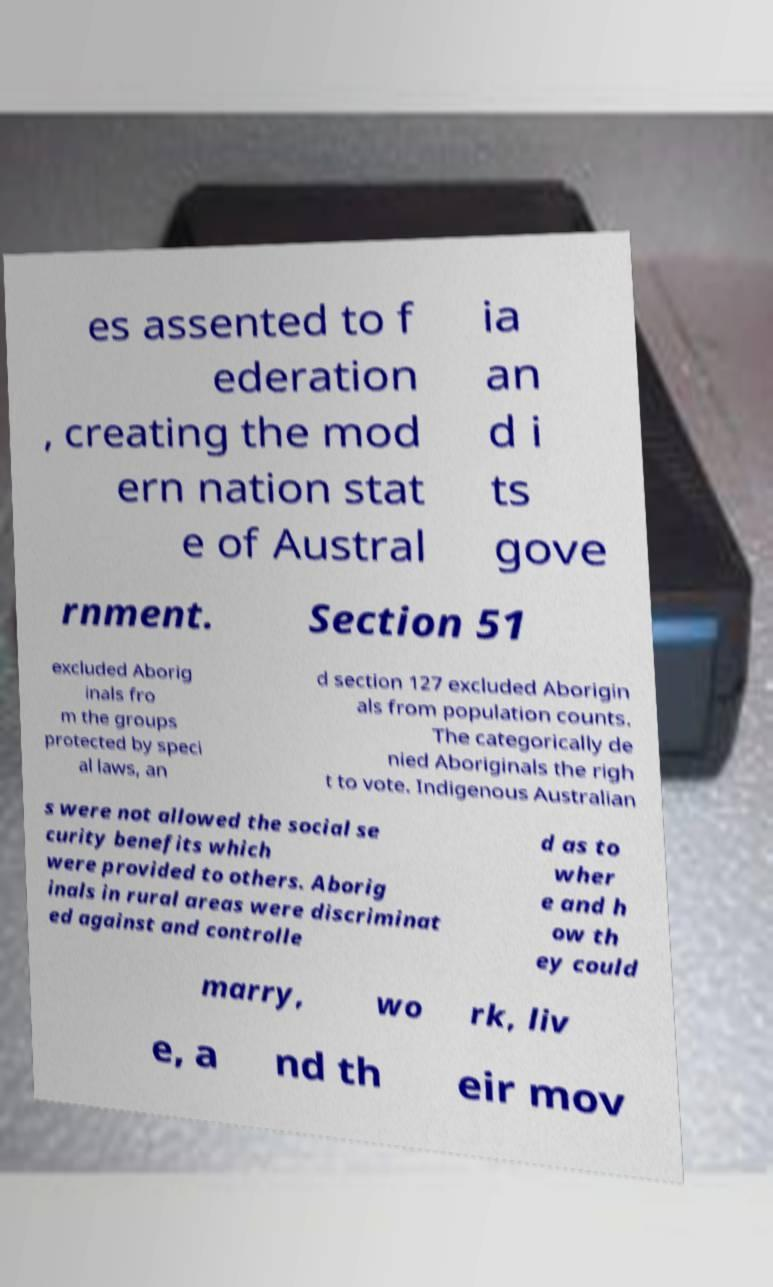There's text embedded in this image that I need extracted. Can you transcribe it verbatim? es assented to f ederation , creating the mod ern nation stat e of Austral ia an d i ts gove rnment. Section 51 excluded Aborig inals fro m the groups protected by speci al laws, an d section 127 excluded Aborigin als from population counts. The categorically de nied Aboriginals the righ t to vote. Indigenous Australian s were not allowed the social se curity benefits which were provided to others. Aborig inals in rural areas were discriminat ed against and controlle d as to wher e and h ow th ey could marry, wo rk, liv e, a nd th eir mov 